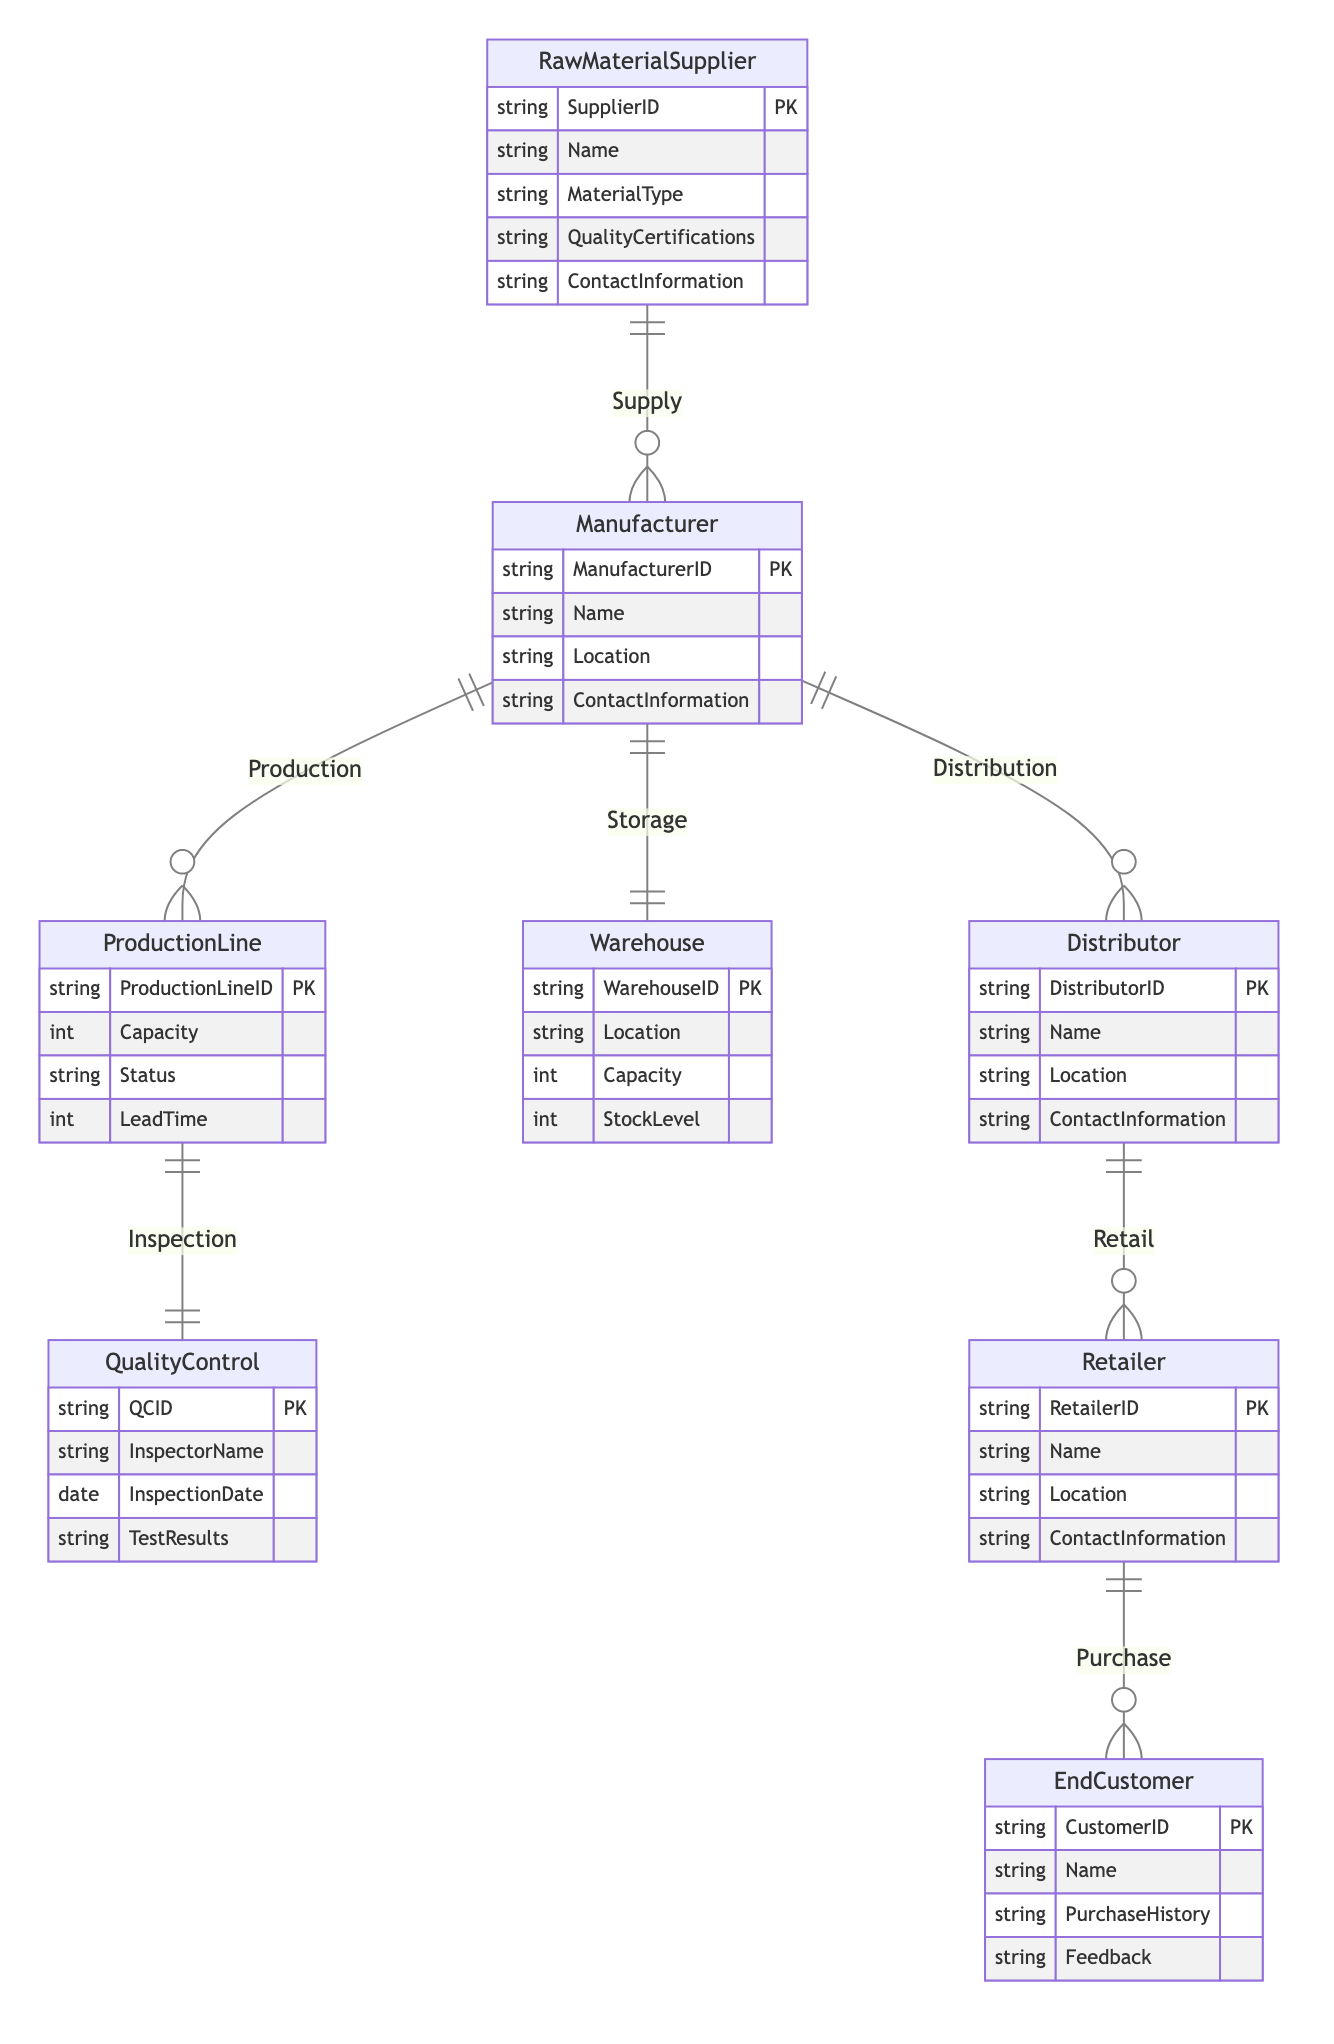What is the maximum number of raw material suppliers a manufacturer can have? The diagram shows a one-to-many relationship between RawMaterialSupplier and Manufacturer, which indicates that a single manufacturer can be supplied by multiple raw material suppliers. Hence, the maximum number would be based on the diagram structure itself and the interpretation of its meaning. However, the precise number is not defined within the diagram itself.
Answer: Many What entity is responsible for conducting quality control? The diagram shows a one-to-one relationship between ProductionLine and QualityControl, meaning each production line has one corresponding quality control entity responsible for inspection.
Answer: QualityControl How many total distinct entities are present in the diagram? By counting the unique entities mentioned in the diagram (Manufacturer, RawMaterialSupplier, ProductionLine, QualityControl, Warehouse, Distributor, Retailer, EndCustomer), we find there are eight distinct entities.
Answer: Eight Who distributes the strings to retailers? The diagram indicates a one-to-many relationship between Distributor and Retailer, meaning that the distributor is responsible for supplying strings to multiple retailers.
Answer: Distributor How many end customers can a retailer serve? Based on the one-to-many relationship between Retailer and EndCustomer, each retailer can serve many end customers, meaning there is no upper limit defined within this structure.
Answer: Many What is the primary purpose of the warehouse in this process? The relationship marked as Storage showing a one-to-one relationship between Manufacturer and Warehouse indicates that the warehouse is primarily used for storing manufactured strings until they are distributed.
Answer: Storage What type of material can raw material suppliers provide? The RawMaterialSupplier entity includes the attribute MaterialType, which specifies that the suppliers can provide a variety of material types used in string manufacturing.
Answer: MaterialType What role does quality control play in the production process? The diagram indicates a one-to-one relationship between ProductionLine and QualityControl, emphasizing that quality control ensures that the strings produced meet required specifications after production.
Answer: Inspection 